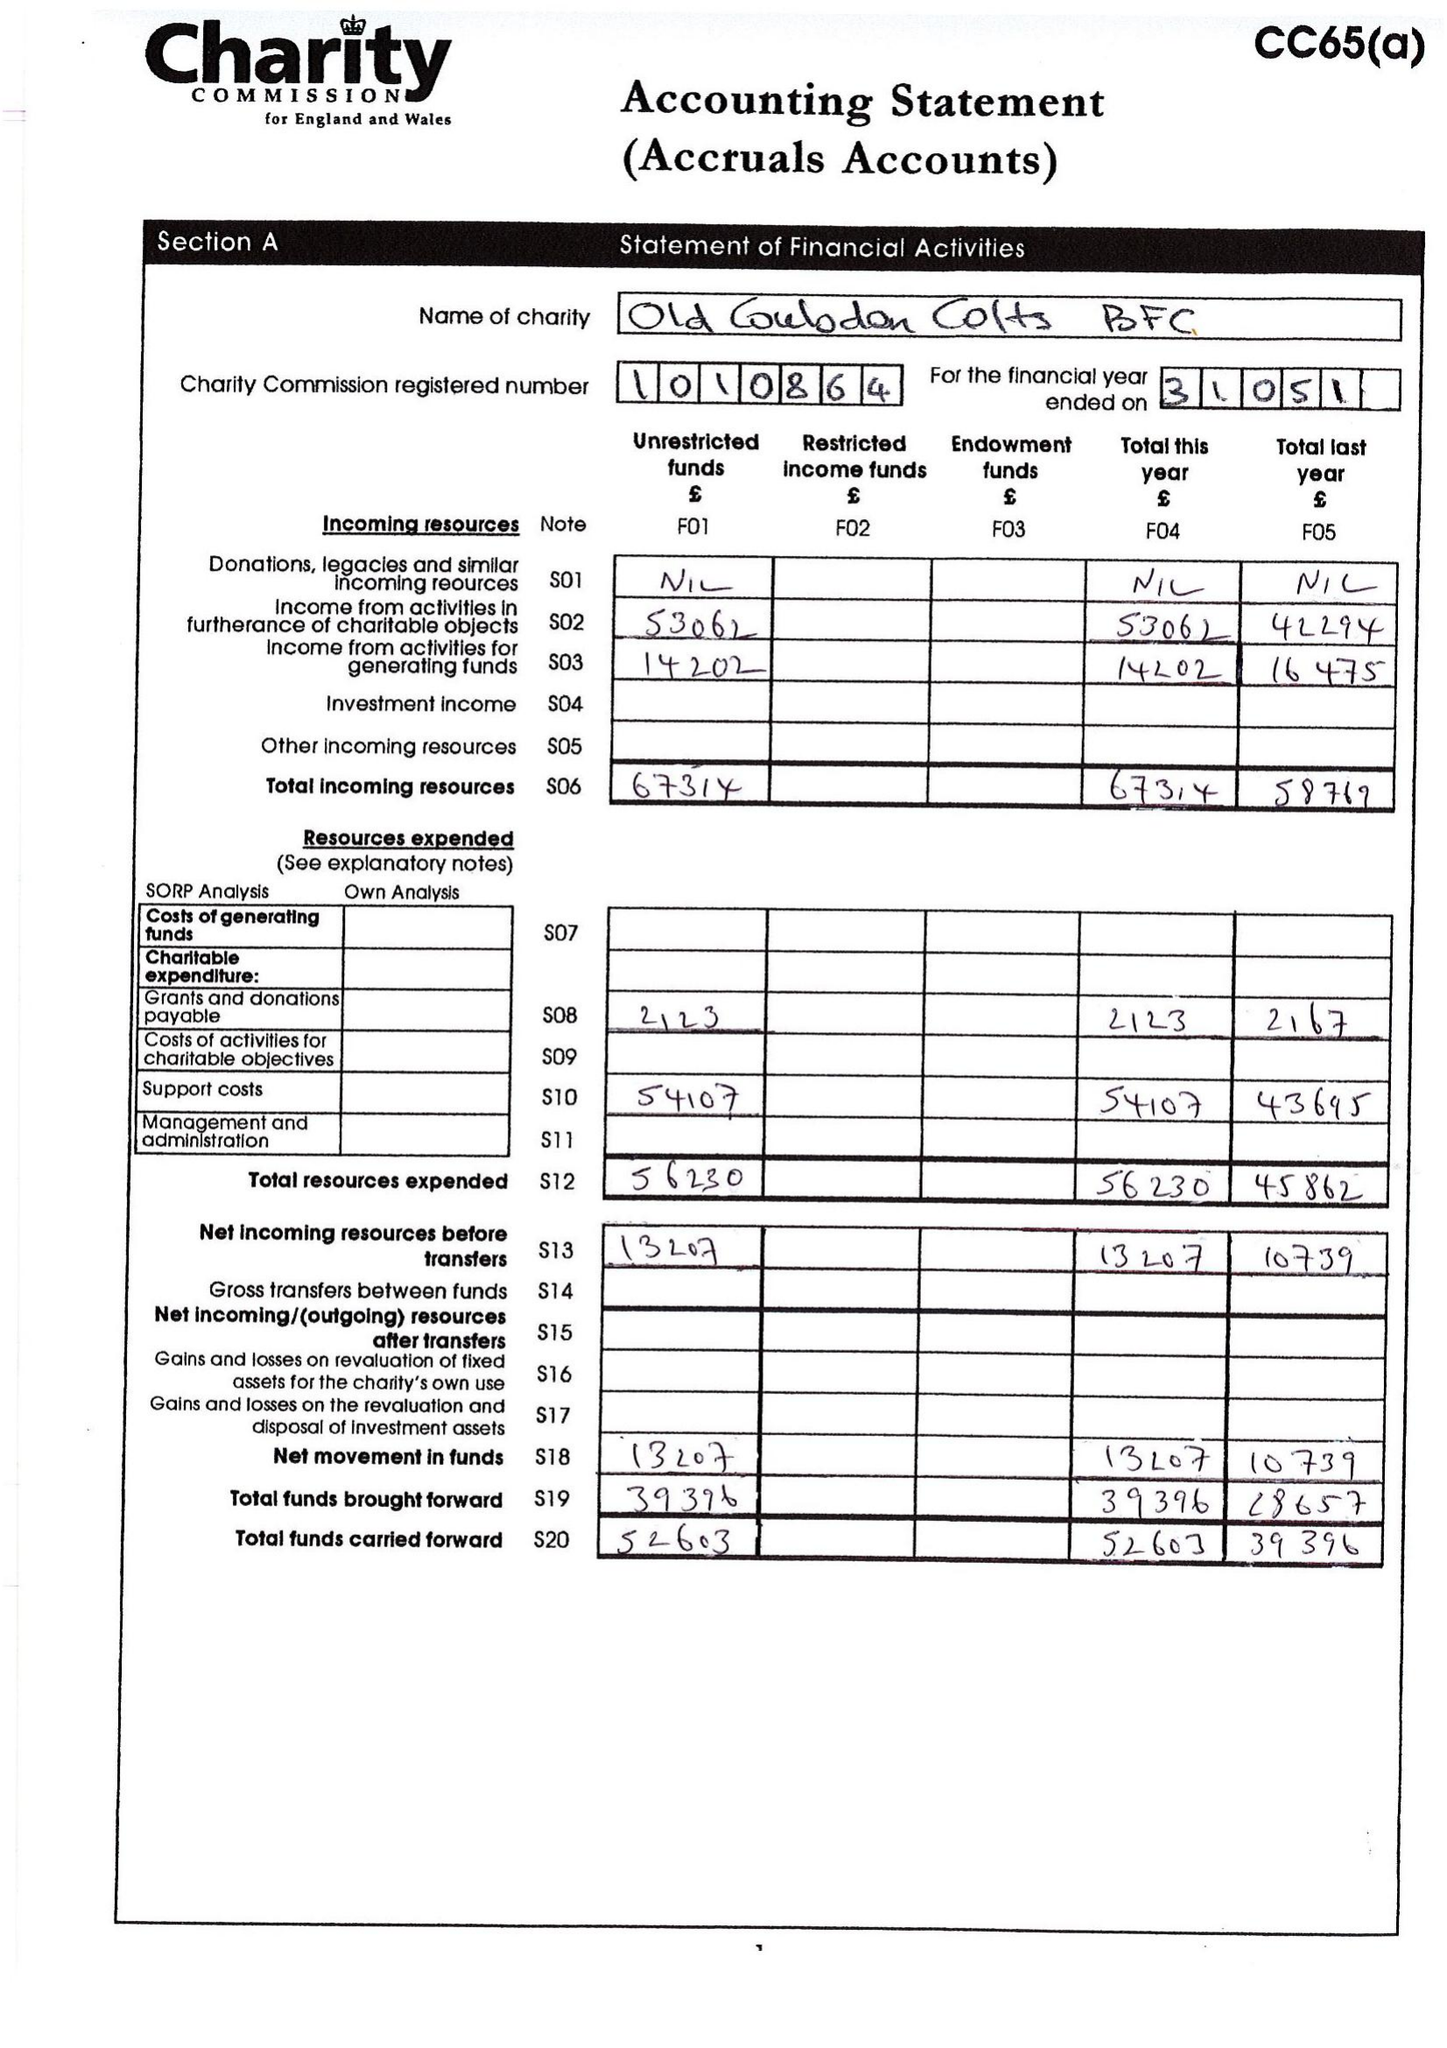What is the value for the address__post_town?
Answer the question using a single word or phrase. COULSDON 